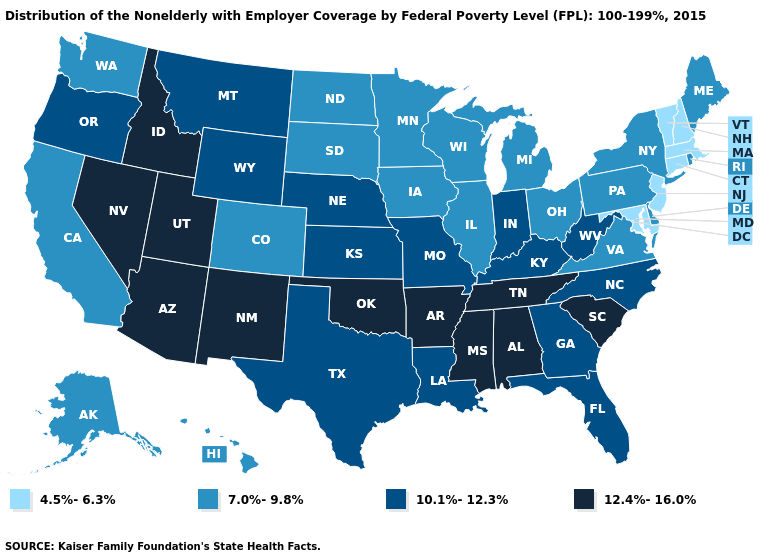What is the value of Massachusetts?
Write a very short answer. 4.5%-6.3%. Name the states that have a value in the range 4.5%-6.3%?
Give a very brief answer. Connecticut, Maryland, Massachusetts, New Hampshire, New Jersey, Vermont. Which states hav the highest value in the South?
Answer briefly. Alabama, Arkansas, Mississippi, Oklahoma, South Carolina, Tennessee. What is the value of Nevada?
Concise answer only. 12.4%-16.0%. Name the states that have a value in the range 10.1%-12.3%?
Write a very short answer. Florida, Georgia, Indiana, Kansas, Kentucky, Louisiana, Missouri, Montana, Nebraska, North Carolina, Oregon, Texas, West Virginia, Wyoming. What is the lowest value in the South?
Answer briefly. 4.5%-6.3%. Does the first symbol in the legend represent the smallest category?
Keep it brief. Yes. What is the value of Oregon?
Short answer required. 10.1%-12.3%. What is the value of Mississippi?
Short answer required. 12.4%-16.0%. Name the states that have a value in the range 4.5%-6.3%?
Be succinct. Connecticut, Maryland, Massachusetts, New Hampshire, New Jersey, Vermont. What is the value of Virginia?
Short answer required. 7.0%-9.8%. Among the states that border Washington , which have the lowest value?
Keep it brief. Oregon. Does Illinois have the lowest value in the USA?
Give a very brief answer. No. Which states have the highest value in the USA?
Answer briefly. Alabama, Arizona, Arkansas, Idaho, Mississippi, Nevada, New Mexico, Oklahoma, South Carolina, Tennessee, Utah. Does Virginia have the highest value in the USA?
Answer briefly. No. 